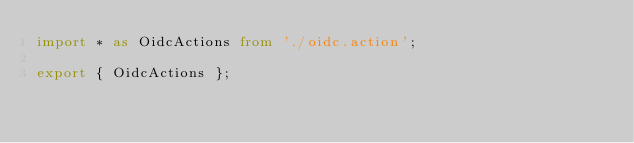<code> <loc_0><loc_0><loc_500><loc_500><_TypeScript_>import * as OidcActions from './oidc.action';

export { OidcActions };
</code> 